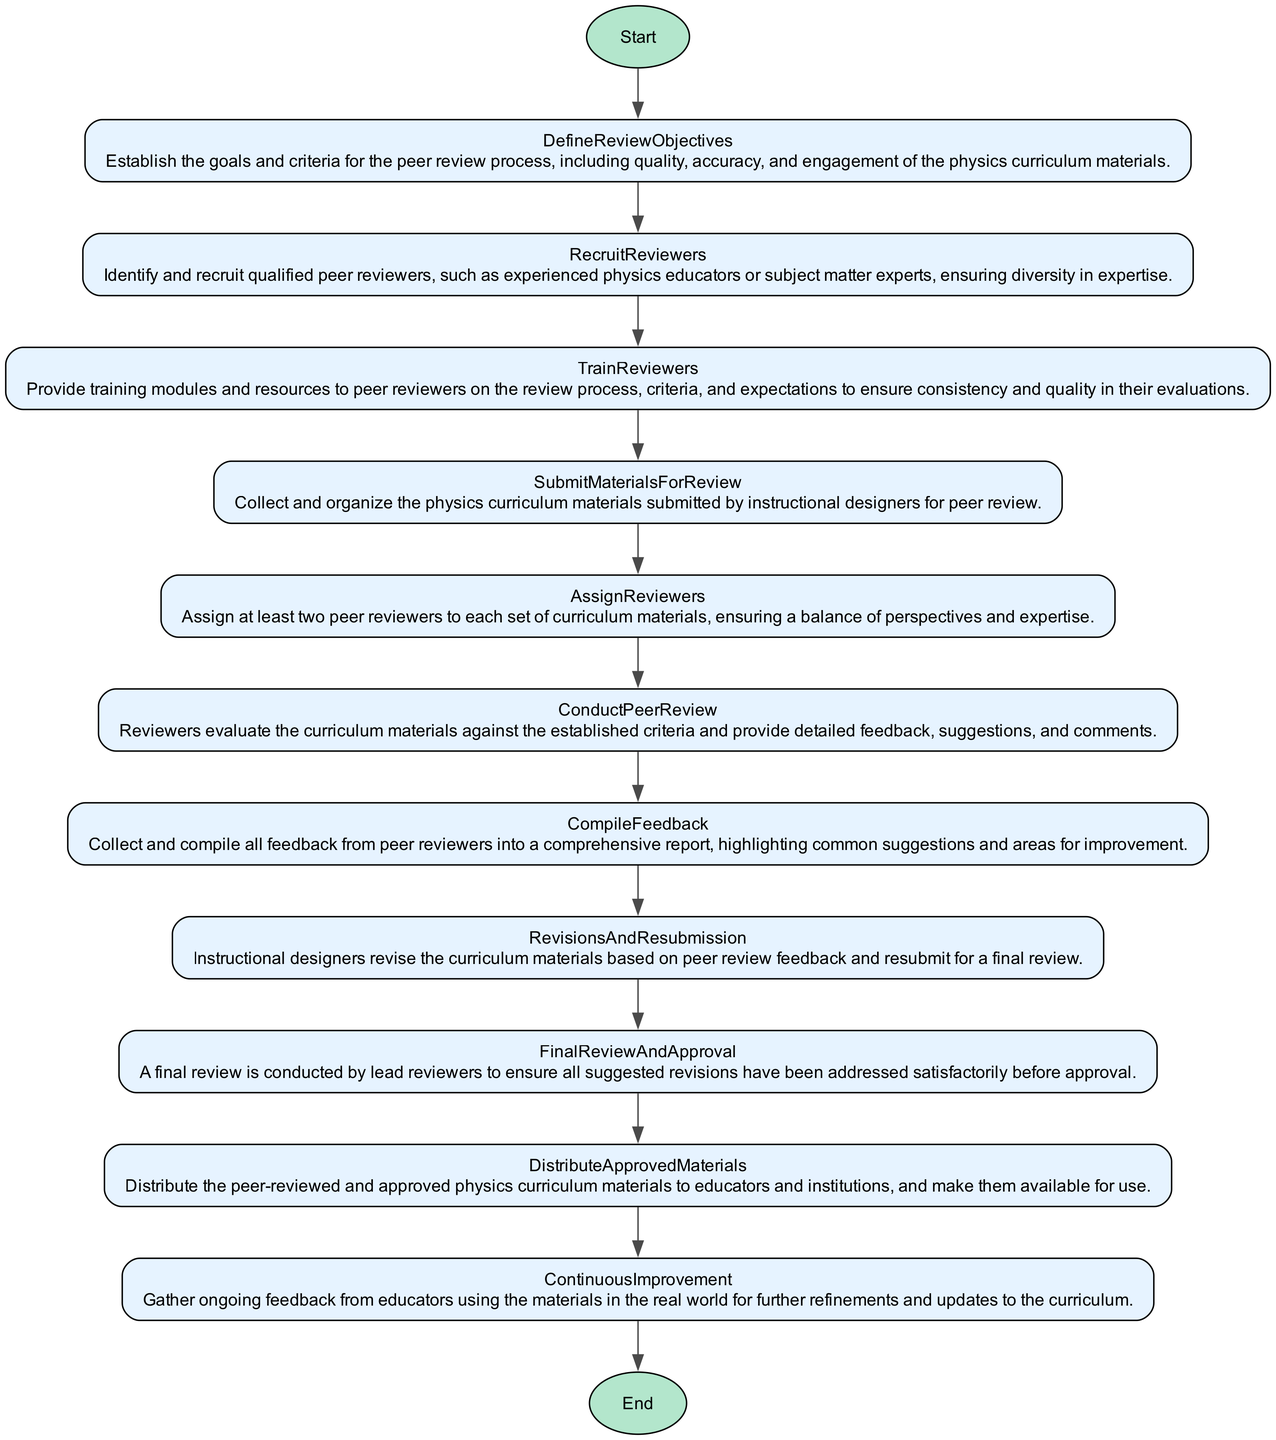What is the first step in the peer review system? The first step listed in the flowchart is "DefineReviewObjectives," which is the first node that connects directly after the "Start" node.
Answer: DefineReviewObjectives How many steps are in the peer review system? By counting the nodes in the flowchart that represent each step, there are a total of 11 steps, including the start and end nodes.
Answer: 11 What is the last step before distributing the approved materials? The last step before distributing materials is "FinalReviewAndApproval," which is directly connected to the "DistributeApprovedMaterials" step in the flowchart.
Answer: FinalReviewAndApproval Which step involves gathering feedback from educators? The step that involves gathering feedback is "ContinuousImprovement," as indicated in the flowchart where it is directly at the end of the process feed into ongoing refinement.
Answer: ContinuousImprovement How many peer reviewers are assigned to each set of materials? The flowchart specifies that at least two peer reviewers are assigned to ensure a diversity of perspectives and expertise, which is stated in the "AssignReviewers" step.
Answer: Two What is the main objective defined in the first step? The main objective outlined in "DefineReviewObjectives" includes quality, accuracy, and engagement of the physics curriculum materials; these keywords encapsulate the key focus of this step.
Answer: quality, accuracy, engagement What happens during the "ConductPeerReview" step? In this step, reviewers evaluate the curriculum materials against the established criteria and provide detailed feedback, which entails close examination and critique of the submitted documents.
Answer: Reviewers evaluate and provide feedback What is the purpose of the "TrainReviewers" step? The purpose of "TrainReviewers" is to ensure that peer reviewers receive the necessary training and resources on the review process, which promotes consistency and quality in evaluations.
Answer: Consistency and quality in evaluations 